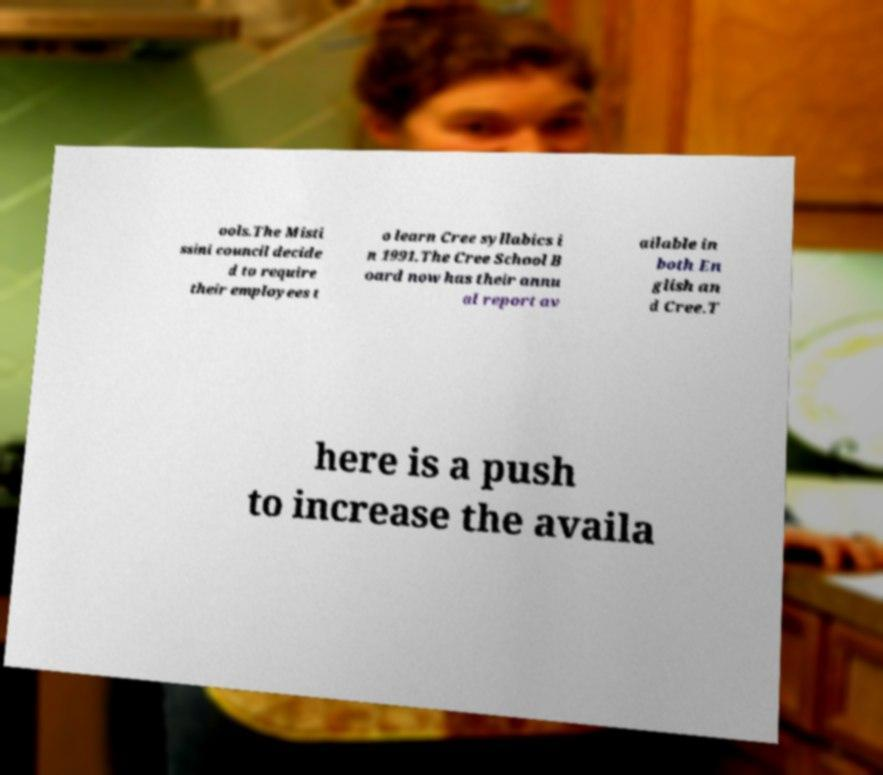I need the written content from this picture converted into text. Can you do that? ools.The Misti ssini council decide d to require their employees t o learn Cree syllabics i n 1991.The Cree School B oard now has their annu al report av ailable in both En glish an d Cree.T here is a push to increase the availa 